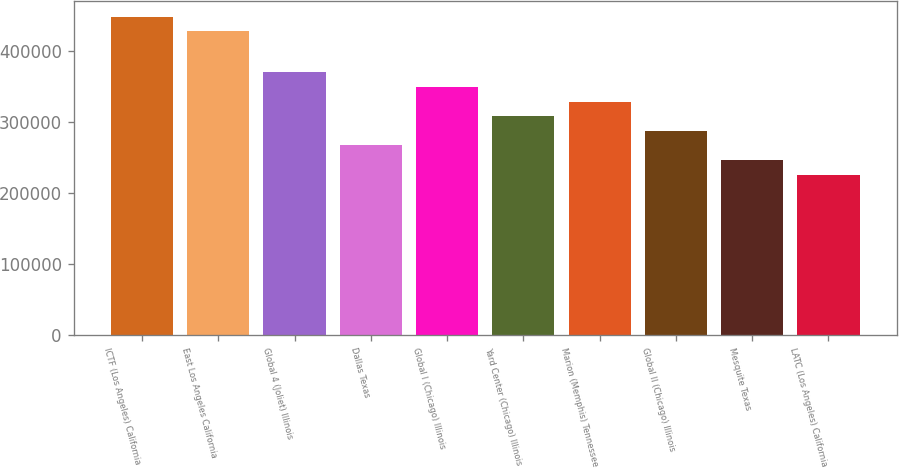Convert chart. <chart><loc_0><loc_0><loc_500><loc_500><bar_chart><fcel>ICTF (Los Angeles) California<fcel>East Los Angeles California<fcel>Global 4 (Joliet) Illinois<fcel>Dallas Texas<fcel>Global I (Chicago) Illinois<fcel>Yard Center (Chicago) Illinois<fcel>Marion (Memphis) Tennessee<fcel>Global II (Chicago) Illinois<fcel>Mesquite Texas<fcel>LATC (Los Angeles) California<nl><fcel>448600<fcel>428000<fcel>370200<fcel>267200<fcel>349600<fcel>308400<fcel>329000<fcel>287800<fcel>246600<fcel>226000<nl></chart> 